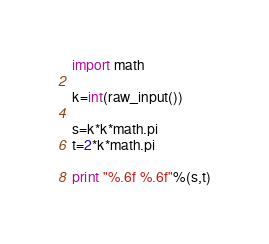<code> <loc_0><loc_0><loc_500><loc_500><_Python_>import math

k=int(raw_input())

s=k*k*math.pi
t=2*k*math.pi

print "%.6f %.6f"%(s,t)</code> 